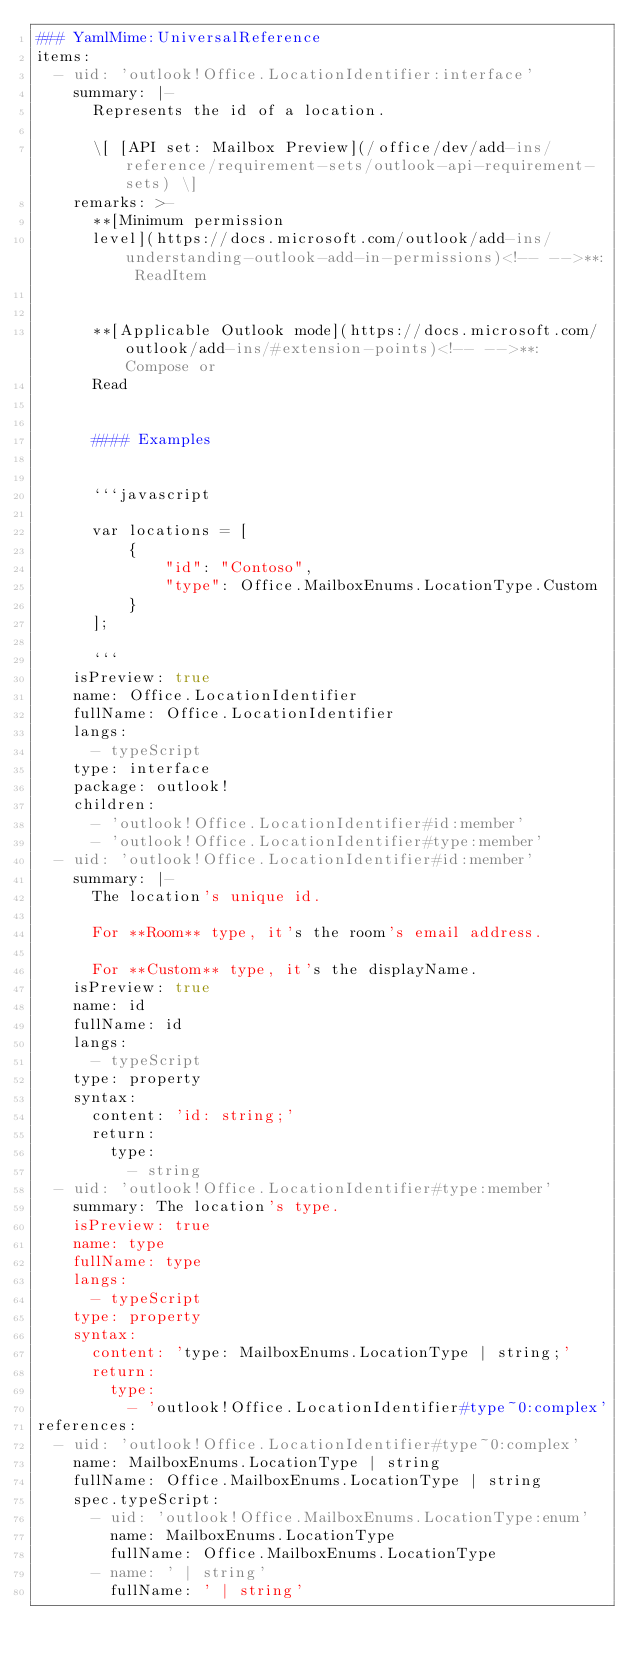<code> <loc_0><loc_0><loc_500><loc_500><_YAML_>### YamlMime:UniversalReference
items:
  - uid: 'outlook!Office.LocationIdentifier:interface'
    summary: |-
      Represents the id of a location.

      \[ [API set: Mailbox Preview](/office/dev/add-ins/reference/requirement-sets/outlook-api-requirement-sets) \]
    remarks: >-
      **[Minimum permission
      level](https://docs.microsoft.com/outlook/add-ins/understanding-outlook-add-in-permissions)<!-- -->**: ReadItem


      **[Applicable Outlook mode](https://docs.microsoft.com/outlook/add-ins/#extension-points)<!-- -->**: Compose or
      Read


      #### Examples


      ```javascript

      var locations = [
          {
              "id": "Contoso",
              "type": Office.MailboxEnums.LocationType.Custom
          }
      ];

      ```
    isPreview: true
    name: Office.LocationIdentifier
    fullName: Office.LocationIdentifier
    langs:
      - typeScript
    type: interface
    package: outlook!
    children:
      - 'outlook!Office.LocationIdentifier#id:member'
      - 'outlook!Office.LocationIdentifier#type:member'
  - uid: 'outlook!Office.LocationIdentifier#id:member'
    summary: |-
      The location's unique id.

      For **Room** type, it's the room's email address.

      For **Custom** type, it's the displayName.
    isPreview: true
    name: id
    fullName: id
    langs:
      - typeScript
    type: property
    syntax:
      content: 'id: string;'
      return:
        type:
          - string
  - uid: 'outlook!Office.LocationIdentifier#type:member'
    summary: The location's type.
    isPreview: true
    name: type
    fullName: type
    langs:
      - typeScript
    type: property
    syntax:
      content: 'type: MailboxEnums.LocationType | string;'
      return:
        type:
          - 'outlook!Office.LocationIdentifier#type~0:complex'
references:
  - uid: 'outlook!Office.LocationIdentifier#type~0:complex'
    name: MailboxEnums.LocationType | string
    fullName: Office.MailboxEnums.LocationType | string
    spec.typeScript:
      - uid: 'outlook!Office.MailboxEnums.LocationType:enum'
        name: MailboxEnums.LocationType
        fullName: Office.MailboxEnums.LocationType
      - name: ' | string'
        fullName: ' | string'
</code> 